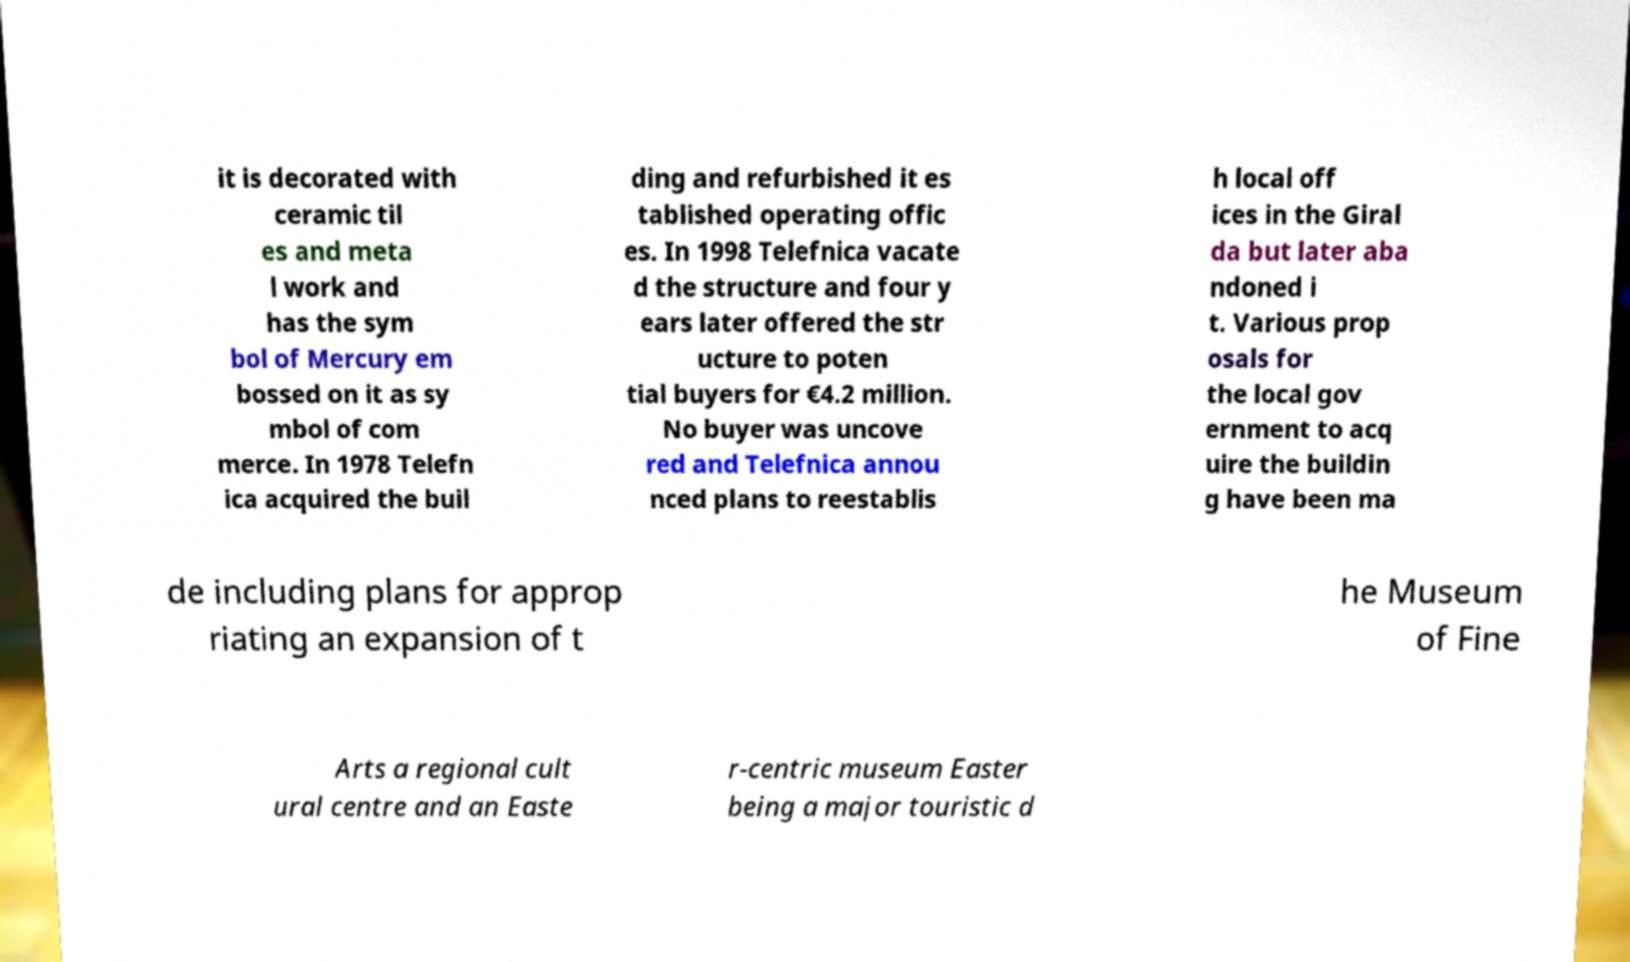Can you read and provide the text displayed in the image?This photo seems to have some interesting text. Can you extract and type it out for me? it is decorated with ceramic til es and meta l work and has the sym bol of Mercury em bossed on it as sy mbol of com merce. In 1978 Telefn ica acquired the buil ding and refurbished it es tablished operating offic es. In 1998 Telefnica vacate d the structure and four y ears later offered the str ucture to poten tial buyers for €4.2 million. No buyer was uncove red and Telefnica annou nced plans to reestablis h local off ices in the Giral da but later aba ndoned i t. Various prop osals for the local gov ernment to acq uire the buildin g have been ma de including plans for approp riating an expansion of t he Museum of Fine Arts a regional cult ural centre and an Easte r-centric museum Easter being a major touristic d 